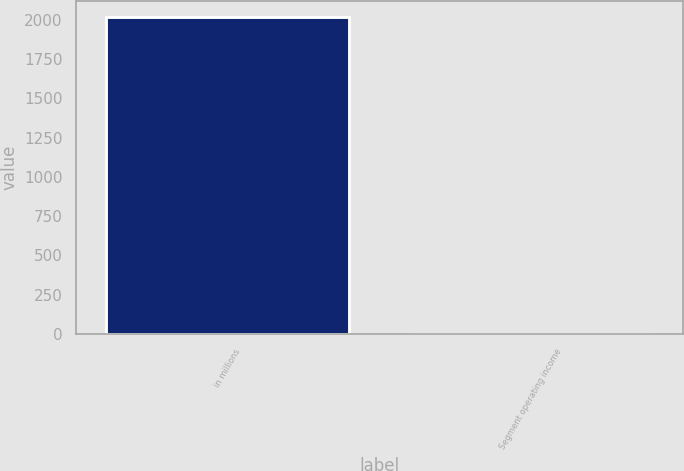Convert chart. <chart><loc_0><loc_0><loc_500><loc_500><bar_chart><fcel>in millions<fcel>Segment operating income<nl><fcel>2017<fcel>1<nl></chart> 